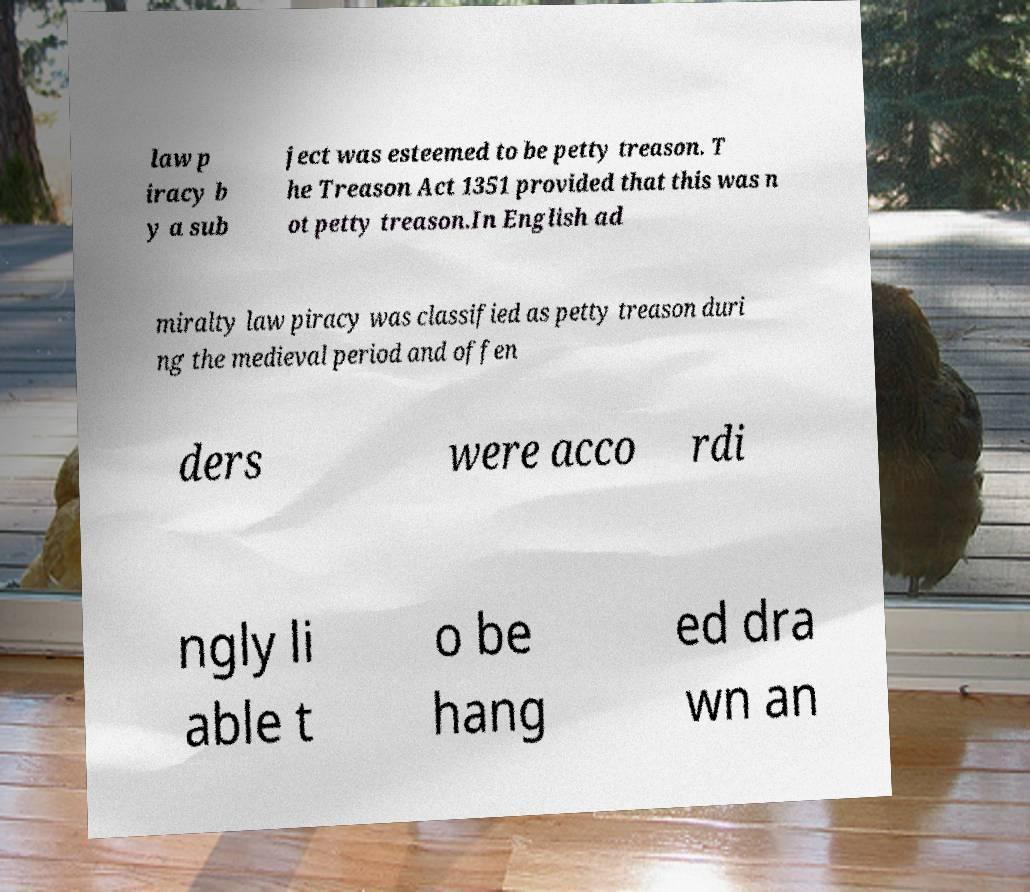I need the written content from this picture converted into text. Can you do that? law p iracy b y a sub ject was esteemed to be petty treason. T he Treason Act 1351 provided that this was n ot petty treason.In English ad miralty law piracy was classified as petty treason duri ng the medieval period and offen ders were acco rdi ngly li able t o be hang ed dra wn an 